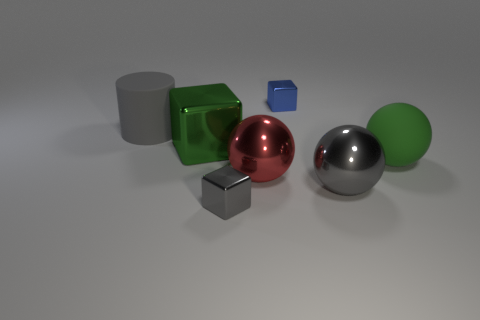Add 2 blue objects. How many objects exist? 9 Subtract all cylinders. How many objects are left? 6 Add 3 matte spheres. How many matte spheres exist? 4 Subtract 1 gray cubes. How many objects are left? 6 Subtract all tiny blue matte spheres. Subtract all big gray metal things. How many objects are left? 6 Add 2 tiny blue objects. How many tiny blue objects are left? 3 